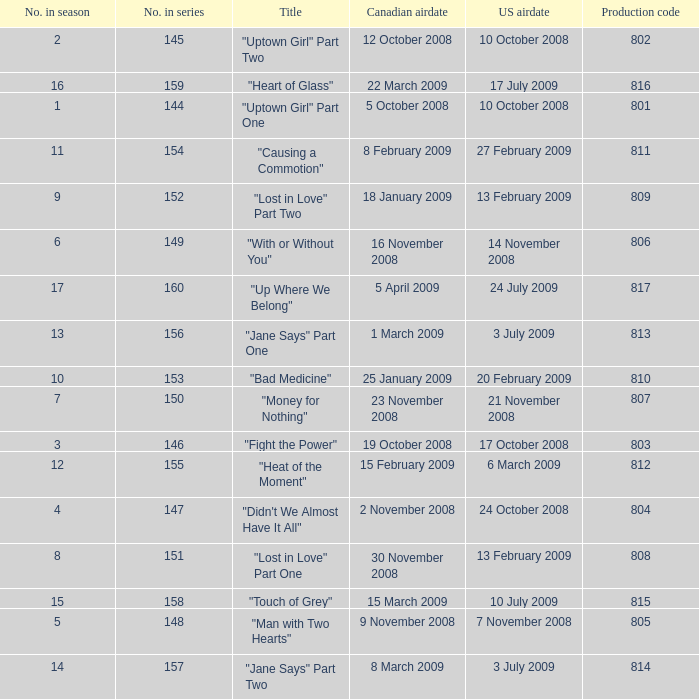What is the latest season number for a show with a production code of 816? 16.0. Help me parse the entirety of this table. {'header': ['No. in season', 'No. in series', 'Title', 'Canadian airdate', 'US airdate', 'Production code'], 'rows': [['2', '145', '"Uptown Girl" Part Two', '12 October 2008', '10 October 2008', '802'], ['16', '159', '"Heart of Glass"', '22 March 2009', '17 July 2009', '816'], ['1', '144', '"Uptown Girl" Part One', '5 October 2008', '10 October 2008', '801'], ['11', '154', '"Causing a Commotion"', '8 February 2009', '27 February 2009', '811'], ['9', '152', '"Lost in Love" Part Two', '18 January 2009', '13 February 2009', '809'], ['6', '149', '"With or Without You"', '16 November 2008', '14 November 2008', '806'], ['17', '160', '"Up Where We Belong"', '5 April 2009', '24 July 2009', '817'], ['13', '156', '"Jane Says" Part One', '1 March 2009', '3 July 2009', '813'], ['10', '153', '"Bad Medicine"', '25 January 2009', '20 February 2009', '810'], ['7', '150', '"Money for Nothing"', '23 November 2008', '21 November 2008', '807'], ['3', '146', '"Fight the Power"', '19 October 2008', '17 October 2008', '803'], ['12', '155', '"Heat of the Moment"', '15 February 2009', '6 March 2009', '812'], ['4', '147', '"Didn\'t We Almost Have It All"', '2 November 2008', '24 October 2008', '804'], ['8', '151', '"Lost in Love" Part One', '30 November 2008', '13 February 2009', '808'], ['15', '158', '"Touch of Grey"', '15 March 2009', '10 July 2009', '815'], ['5', '148', '"Man with Two Hearts"', '9 November 2008', '7 November 2008', '805'], ['14', '157', '"Jane Says" Part Two', '8 March 2009', '3 July 2009', '814']]} 